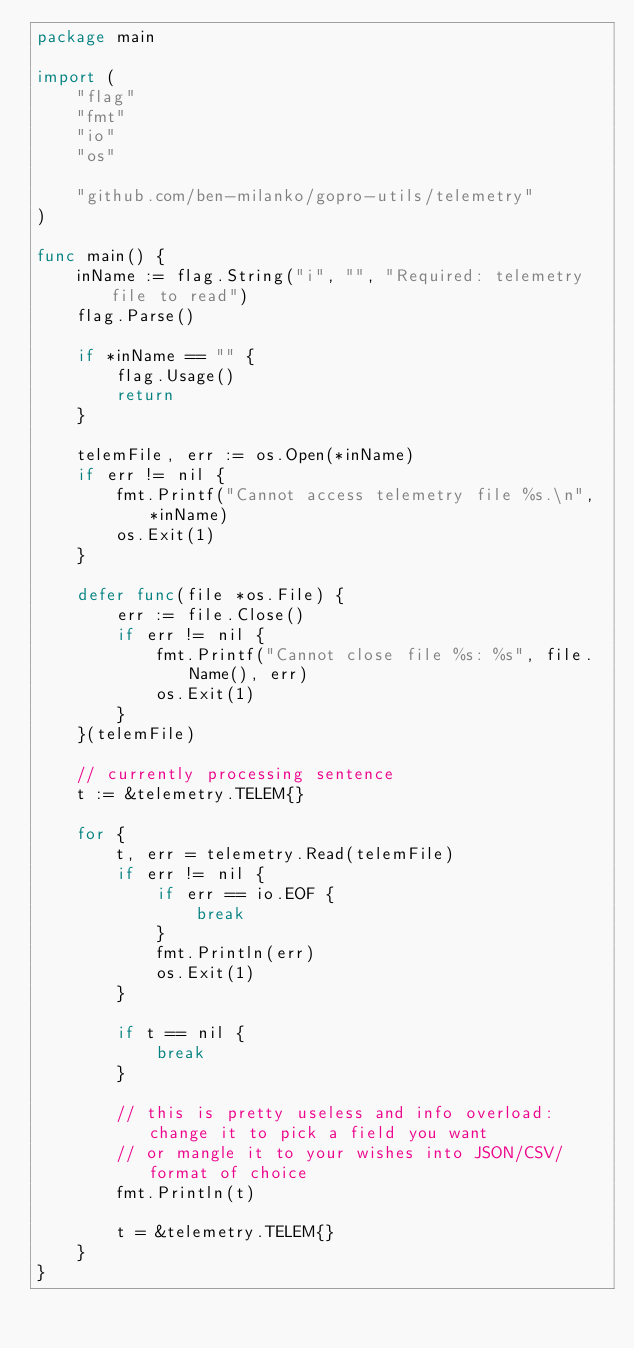<code> <loc_0><loc_0><loc_500><loc_500><_Go_>package main

import (
	"flag"
	"fmt"
	"io"
	"os"

	"github.com/ben-milanko/gopro-utils/telemetry"
)

func main() {
	inName := flag.String("i", "", "Required: telemetry file to read")
	flag.Parse()

	if *inName == "" {
		flag.Usage()
		return
	}

	telemFile, err := os.Open(*inName)
	if err != nil {
		fmt.Printf("Cannot access telemetry file %s.\n", *inName)
		os.Exit(1)
	}

	defer func(file *os.File) {
		err := file.Close()
		if err != nil {
			fmt.Printf("Cannot close file %s: %s", file.Name(), err)
			os.Exit(1)
		}
	}(telemFile)

	// currently processing sentence
	t := &telemetry.TELEM{}

	for {
		t, err = telemetry.Read(telemFile)
		if err != nil {
			if err == io.EOF {
				break
			}
			fmt.Println(err)
			os.Exit(1)
		}

		if t == nil {
			break
		}

		// this is pretty useless and info overload: change it to pick a field you want
		// or mangle it to your wishes into JSON/CSV/format of choice
		fmt.Println(t)

		t = &telemetry.TELEM{}
	}
}
</code> 